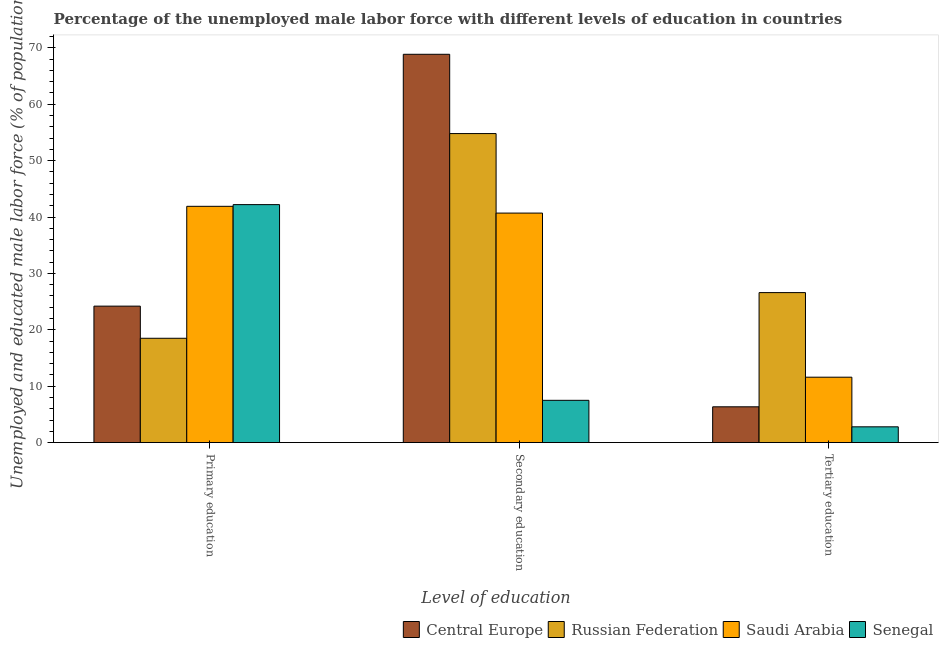How many groups of bars are there?
Offer a terse response. 3. What is the label of the 2nd group of bars from the left?
Give a very brief answer. Secondary education. What is the percentage of male labor force who received tertiary education in Senegal?
Offer a terse response. 2.8. Across all countries, what is the maximum percentage of male labor force who received primary education?
Offer a very short reply. 42.2. Across all countries, what is the minimum percentage of male labor force who received primary education?
Your answer should be compact. 18.5. In which country was the percentage of male labor force who received tertiary education maximum?
Keep it short and to the point. Russian Federation. In which country was the percentage of male labor force who received tertiary education minimum?
Your response must be concise. Senegal. What is the total percentage of male labor force who received secondary education in the graph?
Keep it short and to the point. 171.86. What is the difference between the percentage of male labor force who received tertiary education in Central Europe and that in Saudi Arabia?
Your answer should be compact. -5.25. What is the difference between the percentage of male labor force who received secondary education in Central Europe and the percentage of male labor force who received primary education in Russian Federation?
Your response must be concise. 50.36. What is the average percentage of male labor force who received tertiary education per country?
Your response must be concise. 11.84. What is the difference between the percentage of male labor force who received tertiary education and percentage of male labor force who received primary education in Senegal?
Provide a succinct answer. -39.4. What is the ratio of the percentage of male labor force who received secondary education in Central Europe to that in Saudi Arabia?
Your answer should be very brief. 1.69. Is the difference between the percentage of male labor force who received primary education in Central Europe and Russian Federation greater than the difference between the percentage of male labor force who received secondary education in Central Europe and Russian Federation?
Your response must be concise. No. What is the difference between the highest and the second highest percentage of male labor force who received secondary education?
Give a very brief answer. 14.06. What is the difference between the highest and the lowest percentage of male labor force who received primary education?
Offer a very short reply. 23.7. Is the sum of the percentage of male labor force who received primary education in Saudi Arabia and Senegal greater than the maximum percentage of male labor force who received secondary education across all countries?
Your answer should be compact. Yes. What does the 3rd bar from the left in Tertiary education represents?
Keep it short and to the point. Saudi Arabia. What does the 4th bar from the right in Secondary education represents?
Your response must be concise. Central Europe. Are all the bars in the graph horizontal?
Ensure brevity in your answer.  No. What is the difference between two consecutive major ticks on the Y-axis?
Give a very brief answer. 10. Does the graph contain any zero values?
Offer a very short reply. No. Where does the legend appear in the graph?
Your answer should be very brief. Bottom right. What is the title of the graph?
Keep it short and to the point. Percentage of the unemployed male labor force with different levels of education in countries. Does "Colombia" appear as one of the legend labels in the graph?
Make the answer very short. No. What is the label or title of the X-axis?
Your response must be concise. Level of education. What is the label or title of the Y-axis?
Offer a very short reply. Unemployed and educated male labor force (% of population). What is the Unemployed and educated male labor force (% of population) of Central Europe in Primary education?
Ensure brevity in your answer.  24.2. What is the Unemployed and educated male labor force (% of population) of Saudi Arabia in Primary education?
Give a very brief answer. 41.9. What is the Unemployed and educated male labor force (% of population) of Senegal in Primary education?
Your response must be concise. 42.2. What is the Unemployed and educated male labor force (% of population) of Central Europe in Secondary education?
Provide a short and direct response. 68.86. What is the Unemployed and educated male labor force (% of population) of Russian Federation in Secondary education?
Give a very brief answer. 54.8. What is the Unemployed and educated male labor force (% of population) in Saudi Arabia in Secondary education?
Offer a terse response. 40.7. What is the Unemployed and educated male labor force (% of population) in Central Europe in Tertiary education?
Provide a succinct answer. 6.35. What is the Unemployed and educated male labor force (% of population) of Russian Federation in Tertiary education?
Give a very brief answer. 26.6. What is the Unemployed and educated male labor force (% of population) of Saudi Arabia in Tertiary education?
Keep it short and to the point. 11.6. What is the Unemployed and educated male labor force (% of population) in Senegal in Tertiary education?
Keep it short and to the point. 2.8. Across all Level of education, what is the maximum Unemployed and educated male labor force (% of population) in Central Europe?
Your answer should be compact. 68.86. Across all Level of education, what is the maximum Unemployed and educated male labor force (% of population) in Russian Federation?
Your response must be concise. 54.8. Across all Level of education, what is the maximum Unemployed and educated male labor force (% of population) of Saudi Arabia?
Offer a terse response. 41.9. Across all Level of education, what is the maximum Unemployed and educated male labor force (% of population) of Senegal?
Offer a very short reply. 42.2. Across all Level of education, what is the minimum Unemployed and educated male labor force (% of population) of Central Europe?
Offer a very short reply. 6.35. Across all Level of education, what is the minimum Unemployed and educated male labor force (% of population) of Saudi Arabia?
Your response must be concise. 11.6. Across all Level of education, what is the minimum Unemployed and educated male labor force (% of population) in Senegal?
Your response must be concise. 2.8. What is the total Unemployed and educated male labor force (% of population) in Central Europe in the graph?
Your response must be concise. 99.41. What is the total Unemployed and educated male labor force (% of population) in Russian Federation in the graph?
Your answer should be very brief. 99.9. What is the total Unemployed and educated male labor force (% of population) of Saudi Arabia in the graph?
Provide a succinct answer. 94.2. What is the total Unemployed and educated male labor force (% of population) in Senegal in the graph?
Provide a short and direct response. 52.5. What is the difference between the Unemployed and educated male labor force (% of population) in Central Europe in Primary education and that in Secondary education?
Your answer should be compact. -44.66. What is the difference between the Unemployed and educated male labor force (% of population) of Russian Federation in Primary education and that in Secondary education?
Make the answer very short. -36.3. What is the difference between the Unemployed and educated male labor force (% of population) in Senegal in Primary education and that in Secondary education?
Your response must be concise. 34.7. What is the difference between the Unemployed and educated male labor force (% of population) in Central Europe in Primary education and that in Tertiary education?
Give a very brief answer. 17.85. What is the difference between the Unemployed and educated male labor force (% of population) in Russian Federation in Primary education and that in Tertiary education?
Your answer should be very brief. -8.1. What is the difference between the Unemployed and educated male labor force (% of population) in Saudi Arabia in Primary education and that in Tertiary education?
Your answer should be very brief. 30.3. What is the difference between the Unemployed and educated male labor force (% of population) of Senegal in Primary education and that in Tertiary education?
Offer a terse response. 39.4. What is the difference between the Unemployed and educated male labor force (% of population) in Central Europe in Secondary education and that in Tertiary education?
Give a very brief answer. 62.51. What is the difference between the Unemployed and educated male labor force (% of population) of Russian Federation in Secondary education and that in Tertiary education?
Provide a succinct answer. 28.2. What is the difference between the Unemployed and educated male labor force (% of population) of Saudi Arabia in Secondary education and that in Tertiary education?
Offer a very short reply. 29.1. What is the difference between the Unemployed and educated male labor force (% of population) in Senegal in Secondary education and that in Tertiary education?
Your answer should be compact. 4.7. What is the difference between the Unemployed and educated male labor force (% of population) in Central Europe in Primary education and the Unemployed and educated male labor force (% of population) in Russian Federation in Secondary education?
Provide a short and direct response. -30.6. What is the difference between the Unemployed and educated male labor force (% of population) of Central Europe in Primary education and the Unemployed and educated male labor force (% of population) of Saudi Arabia in Secondary education?
Your response must be concise. -16.5. What is the difference between the Unemployed and educated male labor force (% of population) of Central Europe in Primary education and the Unemployed and educated male labor force (% of population) of Senegal in Secondary education?
Offer a very short reply. 16.7. What is the difference between the Unemployed and educated male labor force (% of population) in Russian Federation in Primary education and the Unemployed and educated male labor force (% of population) in Saudi Arabia in Secondary education?
Offer a terse response. -22.2. What is the difference between the Unemployed and educated male labor force (% of population) of Russian Federation in Primary education and the Unemployed and educated male labor force (% of population) of Senegal in Secondary education?
Offer a very short reply. 11. What is the difference between the Unemployed and educated male labor force (% of population) in Saudi Arabia in Primary education and the Unemployed and educated male labor force (% of population) in Senegal in Secondary education?
Keep it short and to the point. 34.4. What is the difference between the Unemployed and educated male labor force (% of population) in Central Europe in Primary education and the Unemployed and educated male labor force (% of population) in Russian Federation in Tertiary education?
Your answer should be compact. -2.4. What is the difference between the Unemployed and educated male labor force (% of population) of Central Europe in Primary education and the Unemployed and educated male labor force (% of population) of Saudi Arabia in Tertiary education?
Keep it short and to the point. 12.6. What is the difference between the Unemployed and educated male labor force (% of population) of Central Europe in Primary education and the Unemployed and educated male labor force (% of population) of Senegal in Tertiary education?
Keep it short and to the point. 21.4. What is the difference between the Unemployed and educated male labor force (% of population) of Saudi Arabia in Primary education and the Unemployed and educated male labor force (% of population) of Senegal in Tertiary education?
Offer a very short reply. 39.1. What is the difference between the Unemployed and educated male labor force (% of population) of Central Europe in Secondary education and the Unemployed and educated male labor force (% of population) of Russian Federation in Tertiary education?
Keep it short and to the point. 42.26. What is the difference between the Unemployed and educated male labor force (% of population) of Central Europe in Secondary education and the Unemployed and educated male labor force (% of population) of Saudi Arabia in Tertiary education?
Provide a succinct answer. 57.26. What is the difference between the Unemployed and educated male labor force (% of population) in Central Europe in Secondary education and the Unemployed and educated male labor force (% of population) in Senegal in Tertiary education?
Offer a very short reply. 66.06. What is the difference between the Unemployed and educated male labor force (% of population) in Russian Federation in Secondary education and the Unemployed and educated male labor force (% of population) in Saudi Arabia in Tertiary education?
Provide a succinct answer. 43.2. What is the difference between the Unemployed and educated male labor force (% of population) of Saudi Arabia in Secondary education and the Unemployed and educated male labor force (% of population) of Senegal in Tertiary education?
Make the answer very short. 37.9. What is the average Unemployed and educated male labor force (% of population) in Central Europe per Level of education?
Your answer should be very brief. 33.14. What is the average Unemployed and educated male labor force (% of population) in Russian Federation per Level of education?
Ensure brevity in your answer.  33.3. What is the average Unemployed and educated male labor force (% of population) of Saudi Arabia per Level of education?
Your answer should be very brief. 31.4. What is the average Unemployed and educated male labor force (% of population) of Senegal per Level of education?
Your response must be concise. 17.5. What is the difference between the Unemployed and educated male labor force (% of population) in Central Europe and Unemployed and educated male labor force (% of population) in Russian Federation in Primary education?
Keep it short and to the point. 5.7. What is the difference between the Unemployed and educated male labor force (% of population) in Central Europe and Unemployed and educated male labor force (% of population) in Saudi Arabia in Primary education?
Offer a very short reply. -17.7. What is the difference between the Unemployed and educated male labor force (% of population) of Central Europe and Unemployed and educated male labor force (% of population) of Senegal in Primary education?
Provide a short and direct response. -18. What is the difference between the Unemployed and educated male labor force (% of population) in Russian Federation and Unemployed and educated male labor force (% of population) in Saudi Arabia in Primary education?
Your answer should be very brief. -23.4. What is the difference between the Unemployed and educated male labor force (% of population) in Russian Federation and Unemployed and educated male labor force (% of population) in Senegal in Primary education?
Your answer should be compact. -23.7. What is the difference between the Unemployed and educated male labor force (% of population) of Central Europe and Unemployed and educated male labor force (% of population) of Russian Federation in Secondary education?
Make the answer very short. 14.06. What is the difference between the Unemployed and educated male labor force (% of population) in Central Europe and Unemployed and educated male labor force (% of population) in Saudi Arabia in Secondary education?
Make the answer very short. 28.16. What is the difference between the Unemployed and educated male labor force (% of population) in Central Europe and Unemployed and educated male labor force (% of population) in Senegal in Secondary education?
Give a very brief answer. 61.36. What is the difference between the Unemployed and educated male labor force (% of population) in Russian Federation and Unemployed and educated male labor force (% of population) in Senegal in Secondary education?
Your response must be concise. 47.3. What is the difference between the Unemployed and educated male labor force (% of population) in Saudi Arabia and Unemployed and educated male labor force (% of population) in Senegal in Secondary education?
Make the answer very short. 33.2. What is the difference between the Unemployed and educated male labor force (% of population) in Central Europe and Unemployed and educated male labor force (% of population) in Russian Federation in Tertiary education?
Provide a short and direct response. -20.25. What is the difference between the Unemployed and educated male labor force (% of population) of Central Europe and Unemployed and educated male labor force (% of population) of Saudi Arabia in Tertiary education?
Your answer should be very brief. -5.25. What is the difference between the Unemployed and educated male labor force (% of population) in Central Europe and Unemployed and educated male labor force (% of population) in Senegal in Tertiary education?
Your answer should be compact. 3.55. What is the difference between the Unemployed and educated male labor force (% of population) in Russian Federation and Unemployed and educated male labor force (% of population) in Saudi Arabia in Tertiary education?
Offer a terse response. 15. What is the difference between the Unemployed and educated male labor force (% of population) in Russian Federation and Unemployed and educated male labor force (% of population) in Senegal in Tertiary education?
Keep it short and to the point. 23.8. What is the difference between the Unemployed and educated male labor force (% of population) in Saudi Arabia and Unemployed and educated male labor force (% of population) in Senegal in Tertiary education?
Offer a very short reply. 8.8. What is the ratio of the Unemployed and educated male labor force (% of population) of Central Europe in Primary education to that in Secondary education?
Offer a terse response. 0.35. What is the ratio of the Unemployed and educated male labor force (% of population) of Russian Federation in Primary education to that in Secondary education?
Give a very brief answer. 0.34. What is the ratio of the Unemployed and educated male labor force (% of population) in Saudi Arabia in Primary education to that in Secondary education?
Ensure brevity in your answer.  1.03. What is the ratio of the Unemployed and educated male labor force (% of population) of Senegal in Primary education to that in Secondary education?
Provide a succinct answer. 5.63. What is the ratio of the Unemployed and educated male labor force (% of population) of Central Europe in Primary education to that in Tertiary education?
Your answer should be compact. 3.81. What is the ratio of the Unemployed and educated male labor force (% of population) of Russian Federation in Primary education to that in Tertiary education?
Make the answer very short. 0.7. What is the ratio of the Unemployed and educated male labor force (% of population) of Saudi Arabia in Primary education to that in Tertiary education?
Offer a very short reply. 3.61. What is the ratio of the Unemployed and educated male labor force (% of population) in Senegal in Primary education to that in Tertiary education?
Your answer should be very brief. 15.07. What is the ratio of the Unemployed and educated male labor force (% of population) in Central Europe in Secondary education to that in Tertiary education?
Keep it short and to the point. 10.85. What is the ratio of the Unemployed and educated male labor force (% of population) in Russian Federation in Secondary education to that in Tertiary education?
Your answer should be very brief. 2.06. What is the ratio of the Unemployed and educated male labor force (% of population) in Saudi Arabia in Secondary education to that in Tertiary education?
Your answer should be compact. 3.51. What is the ratio of the Unemployed and educated male labor force (% of population) in Senegal in Secondary education to that in Tertiary education?
Offer a very short reply. 2.68. What is the difference between the highest and the second highest Unemployed and educated male labor force (% of population) of Central Europe?
Provide a short and direct response. 44.66. What is the difference between the highest and the second highest Unemployed and educated male labor force (% of population) in Russian Federation?
Your answer should be compact. 28.2. What is the difference between the highest and the second highest Unemployed and educated male labor force (% of population) in Saudi Arabia?
Your response must be concise. 1.2. What is the difference between the highest and the second highest Unemployed and educated male labor force (% of population) in Senegal?
Offer a terse response. 34.7. What is the difference between the highest and the lowest Unemployed and educated male labor force (% of population) in Central Europe?
Provide a succinct answer. 62.51. What is the difference between the highest and the lowest Unemployed and educated male labor force (% of population) in Russian Federation?
Offer a very short reply. 36.3. What is the difference between the highest and the lowest Unemployed and educated male labor force (% of population) of Saudi Arabia?
Your answer should be compact. 30.3. What is the difference between the highest and the lowest Unemployed and educated male labor force (% of population) of Senegal?
Your response must be concise. 39.4. 